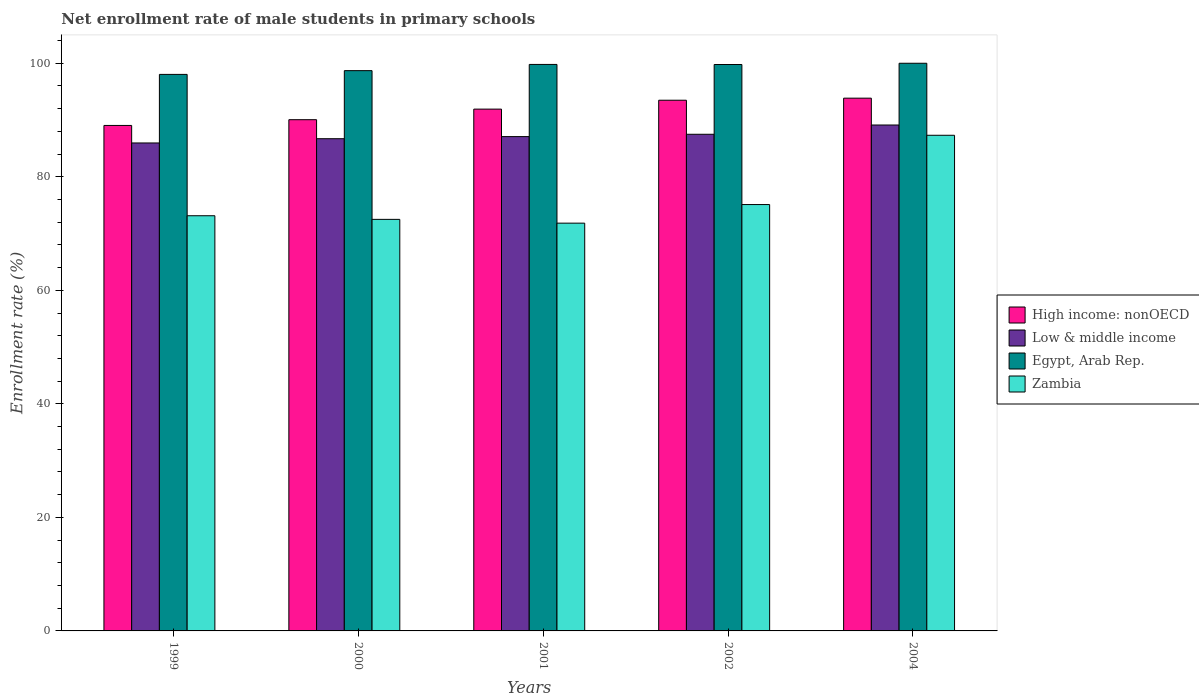Are the number of bars on each tick of the X-axis equal?
Offer a terse response. Yes. What is the net enrollment rate of male students in primary schools in Low & middle income in 2002?
Give a very brief answer. 87.49. Across all years, what is the maximum net enrollment rate of male students in primary schools in Egypt, Arab Rep.?
Offer a terse response. 100. Across all years, what is the minimum net enrollment rate of male students in primary schools in Zambia?
Offer a terse response. 71.83. In which year was the net enrollment rate of male students in primary schools in Egypt, Arab Rep. maximum?
Your answer should be compact. 2004. In which year was the net enrollment rate of male students in primary schools in High income: nonOECD minimum?
Provide a succinct answer. 1999. What is the total net enrollment rate of male students in primary schools in Egypt, Arab Rep. in the graph?
Make the answer very short. 496.3. What is the difference between the net enrollment rate of male students in primary schools in High income: nonOECD in 1999 and that in 2000?
Offer a very short reply. -1.01. What is the difference between the net enrollment rate of male students in primary schools in Low & middle income in 2000 and the net enrollment rate of male students in primary schools in Zambia in 2002?
Give a very brief answer. 11.6. What is the average net enrollment rate of male students in primary schools in Low & middle income per year?
Provide a succinct answer. 87.27. In the year 2001, what is the difference between the net enrollment rate of male students in primary schools in Zambia and net enrollment rate of male students in primary schools in Egypt, Arab Rep.?
Your answer should be very brief. -27.96. In how many years, is the net enrollment rate of male students in primary schools in High income: nonOECD greater than 44 %?
Offer a very short reply. 5. What is the ratio of the net enrollment rate of male students in primary schools in High income: nonOECD in 2002 to that in 2004?
Ensure brevity in your answer.  1. Is the difference between the net enrollment rate of male students in primary schools in Zambia in 1999 and 2001 greater than the difference between the net enrollment rate of male students in primary schools in Egypt, Arab Rep. in 1999 and 2001?
Keep it short and to the point. Yes. What is the difference between the highest and the second highest net enrollment rate of male students in primary schools in High income: nonOECD?
Keep it short and to the point. 0.36. What is the difference between the highest and the lowest net enrollment rate of male students in primary schools in Zambia?
Give a very brief answer. 15.48. Is the sum of the net enrollment rate of male students in primary schools in Low & middle income in 2000 and 2004 greater than the maximum net enrollment rate of male students in primary schools in Zambia across all years?
Your response must be concise. Yes. Is it the case that in every year, the sum of the net enrollment rate of male students in primary schools in Egypt, Arab Rep. and net enrollment rate of male students in primary schools in High income: nonOECD is greater than the sum of net enrollment rate of male students in primary schools in Low & middle income and net enrollment rate of male students in primary schools in Zambia?
Give a very brief answer. No. What does the 3rd bar from the left in 2002 represents?
Ensure brevity in your answer.  Egypt, Arab Rep. Is it the case that in every year, the sum of the net enrollment rate of male students in primary schools in High income: nonOECD and net enrollment rate of male students in primary schools in Zambia is greater than the net enrollment rate of male students in primary schools in Egypt, Arab Rep.?
Your answer should be compact. Yes. How many bars are there?
Ensure brevity in your answer.  20. Are all the bars in the graph horizontal?
Offer a terse response. No. How many years are there in the graph?
Offer a terse response. 5. What is the difference between two consecutive major ticks on the Y-axis?
Make the answer very short. 20. Are the values on the major ticks of Y-axis written in scientific E-notation?
Make the answer very short. No. Does the graph contain grids?
Make the answer very short. No. Where does the legend appear in the graph?
Offer a very short reply. Center right. How many legend labels are there?
Make the answer very short. 4. How are the legend labels stacked?
Provide a succinct answer. Vertical. What is the title of the graph?
Provide a succinct answer. Net enrollment rate of male students in primary schools. Does "Honduras" appear as one of the legend labels in the graph?
Make the answer very short. No. What is the label or title of the Y-axis?
Offer a terse response. Enrollment rate (%). What is the Enrollment rate (%) of High income: nonOECD in 1999?
Give a very brief answer. 89.04. What is the Enrollment rate (%) of Low & middle income in 1999?
Provide a succinct answer. 85.96. What is the Enrollment rate (%) in Egypt, Arab Rep. in 1999?
Provide a succinct answer. 98.04. What is the Enrollment rate (%) in Zambia in 1999?
Provide a short and direct response. 73.14. What is the Enrollment rate (%) of High income: nonOECD in 2000?
Ensure brevity in your answer.  90.06. What is the Enrollment rate (%) in Low & middle income in 2000?
Your answer should be very brief. 86.71. What is the Enrollment rate (%) of Egypt, Arab Rep. in 2000?
Your answer should be compact. 98.7. What is the Enrollment rate (%) in Zambia in 2000?
Provide a short and direct response. 72.5. What is the Enrollment rate (%) in High income: nonOECD in 2001?
Your answer should be very brief. 91.92. What is the Enrollment rate (%) of Low & middle income in 2001?
Make the answer very short. 87.08. What is the Enrollment rate (%) in Egypt, Arab Rep. in 2001?
Provide a short and direct response. 99.79. What is the Enrollment rate (%) of Zambia in 2001?
Your response must be concise. 71.83. What is the Enrollment rate (%) of High income: nonOECD in 2002?
Make the answer very short. 93.49. What is the Enrollment rate (%) in Low & middle income in 2002?
Your answer should be very brief. 87.49. What is the Enrollment rate (%) in Egypt, Arab Rep. in 2002?
Provide a short and direct response. 99.78. What is the Enrollment rate (%) of Zambia in 2002?
Provide a short and direct response. 75.11. What is the Enrollment rate (%) in High income: nonOECD in 2004?
Ensure brevity in your answer.  93.85. What is the Enrollment rate (%) in Low & middle income in 2004?
Provide a short and direct response. 89.12. What is the Enrollment rate (%) of Egypt, Arab Rep. in 2004?
Ensure brevity in your answer.  100. What is the Enrollment rate (%) of Zambia in 2004?
Your response must be concise. 87.31. Across all years, what is the maximum Enrollment rate (%) in High income: nonOECD?
Your answer should be compact. 93.85. Across all years, what is the maximum Enrollment rate (%) of Low & middle income?
Offer a terse response. 89.12. Across all years, what is the maximum Enrollment rate (%) of Egypt, Arab Rep.?
Ensure brevity in your answer.  100. Across all years, what is the maximum Enrollment rate (%) in Zambia?
Offer a terse response. 87.31. Across all years, what is the minimum Enrollment rate (%) in High income: nonOECD?
Offer a very short reply. 89.04. Across all years, what is the minimum Enrollment rate (%) of Low & middle income?
Your response must be concise. 85.96. Across all years, what is the minimum Enrollment rate (%) of Egypt, Arab Rep.?
Ensure brevity in your answer.  98.04. Across all years, what is the minimum Enrollment rate (%) of Zambia?
Give a very brief answer. 71.83. What is the total Enrollment rate (%) in High income: nonOECD in the graph?
Provide a short and direct response. 458.36. What is the total Enrollment rate (%) of Low & middle income in the graph?
Your answer should be very brief. 436.35. What is the total Enrollment rate (%) in Egypt, Arab Rep. in the graph?
Your answer should be very brief. 496.3. What is the total Enrollment rate (%) in Zambia in the graph?
Ensure brevity in your answer.  379.89. What is the difference between the Enrollment rate (%) in High income: nonOECD in 1999 and that in 2000?
Offer a very short reply. -1.01. What is the difference between the Enrollment rate (%) in Low & middle income in 1999 and that in 2000?
Ensure brevity in your answer.  -0.75. What is the difference between the Enrollment rate (%) of Egypt, Arab Rep. in 1999 and that in 2000?
Make the answer very short. -0.66. What is the difference between the Enrollment rate (%) of Zambia in 1999 and that in 2000?
Keep it short and to the point. 0.64. What is the difference between the Enrollment rate (%) of High income: nonOECD in 1999 and that in 2001?
Offer a very short reply. -2.88. What is the difference between the Enrollment rate (%) in Low & middle income in 1999 and that in 2001?
Provide a succinct answer. -1.12. What is the difference between the Enrollment rate (%) of Egypt, Arab Rep. in 1999 and that in 2001?
Offer a very short reply. -1.76. What is the difference between the Enrollment rate (%) in Zambia in 1999 and that in 2001?
Your answer should be very brief. 1.3. What is the difference between the Enrollment rate (%) of High income: nonOECD in 1999 and that in 2002?
Keep it short and to the point. -4.44. What is the difference between the Enrollment rate (%) of Low & middle income in 1999 and that in 2002?
Offer a terse response. -1.53. What is the difference between the Enrollment rate (%) of Egypt, Arab Rep. in 1999 and that in 2002?
Give a very brief answer. -1.74. What is the difference between the Enrollment rate (%) of Zambia in 1999 and that in 2002?
Your answer should be compact. -1.97. What is the difference between the Enrollment rate (%) of High income: nonOECD in 1999 and that in 2004?
Provide a short and direct response. -4.81. What is the difference between the Enrollment rate (%) of Low & middle income in 1999 and that in 2004?
Ensure brevity in your answer.  -3.16. What is the difference between the Enrollment rate (%) in Egypt, Arab Rep. in 1999 and that in 2004?
Your answer should be very brief. -1.96. What is the difference between the Enrollment rate (%) of Zambia in 1999 and that in 2004?
Give a very brief answer. -14.17. What is the difference between the Enrollment rate (%) of High income: nonOECD in 2000 and that in 2001?
Your response must be concise. -1.86. What is the difference between the Enrollment rate (%) of Low & middle income in 2000 and that in 2001?
Ensure brevity in your answer.  -0.37. What is the difference between the Enrollment rate (%) of Egypt, Arab Rep. in 2000 and that in 2001?
Keep it short and to the point. -1.1. What is the difference between the Enrollment rate (%) in Zambia in 2000 and that in 2001?
Ensure brevity in your answer.  0.67. What is the difference between the Enrollment rate (%) in High income: nonOECD in 2000 and that in 2002?
Keep it short and to the point. -3.43. What is the difference between the Enrollment rate (%) in Low & middle income in 2000 and that in 2002?
Make the answer very short. -0.78. What is the difference between the Enrollment rate (%) in Egypt, Arab Rep. in 2000 and that in 2002?
Ensure brevity in your answer.  -1.08. What is the difference between the Enrollment rate (%) in Zambia in 2000 and that in 2002?
Give a very brief answer. -2.61. What is the difference between the Enrollment rate (%) of High income: nonOECD in 2000 and that in 2004?
Provide a short and direct response. -3.79. What is the difference between the Enrollment rate (%) of Low & middle income in 2000 and that in 2004?
Your answer should be very brief. -2.41. What is the difference between the Enrollment rate (%) in Egypt, Arab Rep. in 2000 and that in 2004?
Provide a succinct answer. -1.3. What is the difference between the Enrollment rate (%) of Zambia in 2000 and that in 2004?
Provide a short and direct response. -14.81. What is the difference between the Enrollment rate (%) in High income: nonOECD in 2001 and that in 2002?
Your answer should be very brief. -1.57. What is the difference between the Enrollment rate (%) in Low & middle income in 2001 and that in 2002?
Ensure brevity in your answer.  -0.41. What is the difference between the Enrollment rate (%) of Egypt, Arab Rep. in 2001 and that in 2002?
Your answer should be very brief. 0.01. What is the difference between the Enrollment rate (%) in Zambia in 2001 and that in 2002?
Offer a terse response. -3.28. What is the difference between the Enrollment rate (%) in High income: nonOECD in 2001 and that in 2004?
Ensure brevity in your answer.  -1.93. What is the difference between the Enrollment rate (%) of Low & middle income in 2001 and that in 2004?
Make the answer very short. -2.04. What is the difference between the Enrollment rate (%) in Egypt, Arab Rep. in 2001 and that in 2004?
Give a very brief answer. -0.21. What is the difference between the Enrollment rate (%) in Zambia in 2001 and that in 2004?
Offer a very short reply. -15.48. What is the difference between the Enrollment rate (%) in High income: nonOECD in 2002 and that in 2004?
Make the answer very short. -0.36. What is the difference between the Enrollment rate (%) in Low & middle income in 2002 and that in 2004?
Keep it short and to the point. -1.63. What is the difference between the Enrollment rate (%) in Egypt, Arab Rep. in 2002 and that in 2004?
Your answer should be very brief. -0.22. What is the difference between the Enrollment rate (%) in Zambia in 2002 and that in 2004?
Offer a terse response. -12.2. What is the difference between the Enrollment rate (%) in High income: nonOECD in 1999 and the Enrollment rate (%) in Low & middle income in 2000?
Ensure brevity in your answer.  2.34. What is the difference between the Enrollment rate (%) of High income: nonOECD in 1999 and the Enrollment rate (%) of Egypt, Arab Rep. in 2000?
Ensure brevity in your answer.  -9.65. What is the difference between the Enrollment rate (%) of High income: nonOECD in 1999 and the Enrollment rate (%) of Zambia in 2000?
Offer a terse response. 16.54. What is the difference between the Enrollment rate (%) of Low & middle income in 1999 and the Enrollment rate (%) of Egypt, Arab Rep. in 2000?
Provide a succinct answer. -12.74. What is the difference between the Enrollment rate (%) in Low & middle income in 1999 and the Enrollment rate (%) in Zambia in 2000?
Provide a succinct answer. 13.46. What is the difference between the Enrollment rate (%) in Egypt, Arab Rep. in 1999 and the Enrollment rate (%) in Zambia in 2000?
Your response must be concise. 25.54. What is the difference between the Enrollment rate (%) of High income: nonOECD in 1999 and the Enrollment rate (%) of Low & middle income in 2001?
Provide a succinct answer. 1.96. What is the difference between the Enrollment rate (%) of High income: nonOECD in 1999 and the Enrollment rate (%) of Egypt, Arab Rep. in 2001?
Give a very brief answer. -10.75. What is the difference between the Enrollment rate (%) in High income: nonOECD in 1999 and the Enrollment rate (%) in Zambia in 2001?
Provide a short and direct response. 17.21. What is the difference between the Enrollment rate (%) in Low & middle income in 1999 and the Enrollment rate (%) in Egypt, Arab Rep. in 2001?
Keep it short and to the point. -13.84. What is the difference between the Enrollment rate (%) in Low & middle income in 1999 and the Enrollment rate (%) in Zambia in 2001?
Provide a short and direct response. 14.12. What is the difference between the Enrollment rate (%) of Egypt, Arab Rep. in 1999 and the Enrollment rate (%) of Zambia in 2001?
Provide a short and direct response. 26.2. What is the difference between the Enrollment rate (%) in High income: nonOECD in 1999 and the Enrollment rate (%) in Low & middle income in 2002?
Give a very brief answer. 1.56. What is the difference between the Enrollment rate (%) in High income: nonOECD in 1999 and the Enrollment rate (%) in Egypt, Arab Rep. in 2002?
Your answer should be very brief. -10.73. What is the difference between the Enrollment rate (%) in High income: nonOECD in 1999 and the Enrollment rate (%) in Zambia in 2002?
Offer a very short reply. 13.93. What is the difference between the Enrollment rate (%) of Low & middle income in 1999 and the Enrollment rate (%) of Egypt, Arab Rep. in 2002?
Your answer should be compact. -13.82. What is the difference between the Enrollment rate (%) in Low & middle income in 1999 and the Enrollment rate (%) in Zambia in 2002?
Make the answer very short. 10.85. What is the difference between the Enrollment rate (%) in Egypt, Arab Rep. in 1999 and the Enrollment rate (%) in Zambia in 2002?
Provide a short and direct response. 22.93. What is the difference between the Enrollment rate (%) in High income: nonOECD in 1999 and the Enrollment rate (%) in Low & middle income in 2004?
Ensure brevity in your answer.  -0.08. What is the difference between the Enrollment rate (%) in High income: nonOECD in 1999 and the Enrollment rate (%) in Egypt, Arab Rep. in 2004?
Your response must be concise. -10.95. What is the difference between the Enrollment rate (%) in High income: nonOECD in 1999 and the Enrollment rate (%) in Zambia in 2004?
Your answer should be compact. 1.73. What is the difference between the Enrollment rate (%) of Low & middle income in 1999 and the Enrollment rate (%) of Egypt, Arab Rep. in 2004?
Provide a short and direct response. -14.04. What is the difference between the Enrollment rate (%) in Low & middle income in 1999 and the Enrollment rate (%) in Zambia in 2004?
Make the answer very short. -1.35. What is the difference between the Enrollment rate (%) of Egypt, Arab Rep. in 1999 and the Enrollment rate (%) of Zambia in 2004?
Your response must be concise. 10.73. What is the difference between the Enrollment rate (%) in High income: nonOECD in 2000 and the Enrollment rate (%) in Low & middle income in 2001?
Offer a very short reply. 2.98. What is the difference between the Enrollment rate (%) in High income: nonOECD in 2000 and the Enrollment rate (%) in Egypt, Arab Rep. in 2001?
Ensure brevity in your answer.  -9.74. What is the difference between the Enrollment rate (%) of High income: nonOECD in 2000 and the Enrollment rate (%) of Zambia in 2001?
Your response must be concise. 18.22. What is the difference between the Enrollment rate (%) of Low & middle income in 2000 and the Enrollment rate (%) of Egypt, Arab Rep. in 2001?
Your answer should be very brief. -13.09. What is the difference between the Enrollment rate (%) in Low & middle income in 2000 and the Enrollment rate (%) in Zambia in 2001?
Provide a succinct answer. 14.87. What is the difference between the Enrollment rate (%) in Egypt, Arab Rep. in 2000 and the Enrollment rate (%) in Zambia in 2001?
Provide a succinct answer. 26.86. What is the difference between the Enrollment rate (%) of High income: nonOECD in 2000 and the Enrollment rate (%) of Low & middle income in 2002?
Keep it short and to the point. 2.57. What is the difference between the Enrollment rate (%) of High income: nonOECD in 2000 and the Enrollment rate (%) of Egypt, Arab Rep. in 2002?
Offer a terse response. -9.72. What is the difference between the Enrollment rate (%) in High income: nonOECD in 2000 and the Enrollment rate (%) in Zambia in 2002?
Your answer should be compact. 14.95. What is the difference between the Enrollment rate (%) of Low & middle income in 2000 and the Enrollment rate (%) of Egypt, Arab Rep. in 2002?
Ensure brevity in your answer.  -13.07. What is the difference between the Enrollment rate (%) of Low & middle income in 2000 and the Enrollment rate (%) of Zambia in 2002?
Make the answer very short. 11.6. What is the difference between the Enrollment rate (%) in Egypt, Arab Rep. in 2000 and the Enrollment rate (%) in Zambia in 2002?
Provide a succinct answer. 23.59. What is the difference between the Enrollment rate (%) in High income: nonOECD in 2000 and the Enrollment rate (%) in Low & middle income in 2004?
Provide a succinct answer. 0.94. What is the difference between the Enrollment rate (%) of High income: nonOECD in 2000 and the Enrollment rate (%) of Egypt, Arab Rep. in 2004?
Offer a very short reply. -9.94. What is the difference between the Enrollment rate (%) of High income: nonOECD in 2000 and the Enrollment rate (%) of Zambia in 2004?
Ensure brevity in your answer.  2.74. What is the difference between the Enrollment rate (%) in Low & middle income in 2000 and the Enrollment rate (%) in Egypt, Arab Rep. in 2004?
Offer a very short reply. -13.29. What is the difference between the Enrollment rate (%) in Low & middle income in 2000 and the Enrollment rate (%) in Zambia in 2004?
Your answer should be compact. -0.6. What is the difference between the Enrollment rate (%) in Egypt, Arab Rep. in 2000 and the Enrollment rate (%) in Zambia in 2004?
Give a very brief answer. 11.38. What is the difference between the Enrollment rate (%) of High income: nonOECD in 2001 and the Enrollment rate (%) of Low & middle income in 2002?
Offer a terse response. 4.43. What is the difference between the Enrollment rate (%) of High income: nonOECD in 2001 and the Enrollment rate (%) of Egypt, Arab Rep. in 2002?
Make the answer very short. -7.86. What is the difference between the Enrollment rate (%) in High income: nonOECD in 2001 and the Enrollment rate (%) in Zambia in 2002?
Ensure brevity in your answer.  16.81. What is the difference between the Enrollment rate (%) in Low & middle income in 2001 and the Enrollment rate (%) in Egypt, Arab Rep. in 2002?
Your answer should be compact. -12.7. What is the difference between the Enrollment rate (%) of Low & middle income in 2001 and the Enrollment rate (%) of Zambia in 2002?
Keep it short and to the point. 11.97. What is the difference between the Enrollment rate (%) of Egypt, Arab Rep. in 2001 and the Enrollment rate (%) of Zambia in 2002?
Give a very brief answer. 24.68. What is the difference between the Enrollment rate (%) of High income: nonOECD in 2001 and the Enrollment rate (%) of Low & middle income in 2004?
Make the answer very short. 2.8. What is the difference between the Enrollment rate (%) of High income: nonOECD in 2001 and the Enrollment rate (%) of Egypt, Arab Rep. in 2004?
Your answer should be compact. -8.08. What is the difference between the Enrollment rate (%) of High income: nonOECD in 2001 and the Enrollment rate (%) of Zambia in 2004?
Offer a very short reply. 4.61. What is the difference between the Enrollment rate (%) in Low & middle income in 2001 and the Enrollment rate (%) in Egypt, Arab Rep. in 2004?
Provide a succinct answer. -12.92. What is the difference between the Enrollment rate (%) of Low & middle income in 2001 and the Enrollment rate (%) of Zambia in 2004?
Your answer should be very brief. -0.23. What is the difference between the Enrollment rate (%) of Egypt, Arab Rep. in 2001 and the Enrollment rate (%) of Zambia in 2004?
Keep it short and to the point. 12.48. What is the difference between the Enrollment rate (%) in High income: nonOECD in 2002 and the Enrollment rate (%) in Low & middle income in 2004?
Your answer should be compact. 4.37. What is the difference between the Enrollment rate (%) of High income: nonOECD in 2002 and the Enrollment rate (%) of Egypt, Arab Rep. in 2004?
Your answer should be very brief. -6.51. What is the difference between the Enrollment rate (%) of High income: nonOECD in 2002 and the Enrollment rate (%) of Zambia in 2004?
Keep it short and to the point. 6.18. What is the difference between the Enrollment rate (%) of Low & middle income in 2002 and the Enrollment rate (%) of Egypt, Arab Rep. in 2004?
Keep it short and to the point. -12.51. What is the difference between the Enrollment rate (%) of Low & middle income in 2002 and the Enrollment rate (%) of Zambia in 2004?
Your response must be concise. 0.18. What is the difference between the Enrollment rate (%) of Egypt, Arab Rep. in 2002 and the Enrollment rate (%) of Zambia in 2004?
Provide a short and direct response. 12.47. What is the average Enrollment rate (%) in High income: nonOECD per year?
Offer a terse response. 91.67. What is the average Enrollment rate (%) in Low & middle income per year?
Give a very brief answer. 87.27. What is the average Enrollment rate (%) of Egypt, Arab Rep. per year?
Keep it short and to the point. 99.26. What is the average Enrollment rate (%) in Zambia per year?
Keep it short and to the point. 75.98. In the year 1999, what is the difference between the Enrollment rate (%) in High income: nonOECD and Enrollment rate (%) in Low & middle income?
Make the answer very short. 3.09. In the year 1999, what is the difference between the Enrollment rate (%) of High income: nonOECD and Enrollment rate (%) of Egypt, Arab Rep.?
Provide a succinct answer. -8.99. In the year 1999, what is the difference between the Enrollment rate (%) of High income: nonOECD and Enrollment rate (%) of Zambia?
Give a very brief answer. 15.91. In the year 1999, what is the difference between the Enrollment rate (%) in Low & middle income and Enrollment rate (%) in Egypt, Arab Rep.?
Provide a succinct answer. -12.08. In the year 1999, what is the difference between the Enrollment rate (%) in Low & middle income and Enrollment rate (%) in Zambia?
Give a very brief answer. 12.82. In the year 1999, what is the difference between the Enrollment rate (%) of Egypt, Arab Rep. and Enrollment rate (%) of Zambia?
Provide a short and direct response. 24.9. In the year 2000, what is the difference between the Enrollment rate (%) in High income: nonOECD and Enrollment rate (%) in Low & middle income?
Offer a terse response. 3.35. In the year 2000, what is the difference between the Enrollment rate (%) of High income: nonOECD and Enrollment rate (%) of Egypt, Arab Rep.?
Make the answer very short. -8.64. In the year 2000, what is the difference between the Enrollment rate (%) of High income: nonOECD and Enrollment rate (%) of Zambia?
Your answer should be very brief. 17.56. In the year 2000, what is the difference between the Enrollment rate (%) in Low & middle income and Enrollment rate (%) in Egypt, Arab Rep.?
Ensure brevity in your answer.  -11.99. In the year 2000, what is the difference between the Enrollment rate (%) of Low & middle income and Enrollment rate (%) of Zambia?
Provide a succinct answer. 14.21. In the year 2000, what is the difference between the Enrollment rate (%) in Egypt, Arab Rep. and Enrollment rate (%) in Zambia?
Your response must be concise. 26.2. In the year 2001, what is the difference between the Enrollment rate (%) in High income: nonOECD and Enrollment rate (%) in Low & middle income?
Your answer should be compact. 4.84. In the year 2001, what is the difference between the Enrollment rate (%) of High income: nonOECD and Enrollment rate (%) of Egypt, Arab Rep.?
Provide a succinct answer. -7.87. In the year 2001, what is the difference between the Enrollment rate (%) in High income: nonOECD and Enrollment rate (%) in Zambia?
Offer a terse response. 20.09. In the year 2001, what is the difference between the Enrollment rate (%) of Low & middle income and Enrollment rate (%) of Egypt, Arab Rep.?
Offer a terse response. -12.71. In the year 2001, what is the difference between the Enrollment rate (%) in Low & middle income and Enrollment rate (%) in Zambia?
Provide a succinct answer. 15.25. In the year 2001, what is the difference between the Enrollment rate (%) in Egypt, Arab Rep. and Enrollment rate (%) in Zambia?
Provide a succinct answer. 27.96. In the year 2002, what is the difference between the Enrollment rate (%) of High income: nonOECD and Enrollment rate (%) of Low & middle income?
Make the answer very short. 6. In the year 2002, what is the difference between the Enrollment rate (%) in High income: nonOECD and Enrollment rate (%) in Egypt, Arab Rep.?
Offer a very short reply. -6.29. In the year 2002, what is the difference between the Enrollment rate (%) of High income: nonOECD and Enrollment rate (%) of Zambia?
Offer a terse response. 18.38. In the year 2002, what is the difference between the Enrollment rate (%) of Low & middle income and Enrollment rate (%) of Egypt, Arab Rep.?
Your response must be concise. -12.29. In the year 2002, what is the difference between the Enrollment rate (%) of Low & middle income and Enrollment rate (%) of Zambia?
Your answer should be compact. 12.38. In the year 2002, what is the difference between the Enrollment rate (%) in Egypt, Arab Rep. and Enrollment rate (%) in Zambia?
Your answer should be very brief. 24.67. In the year 2004, what is the difference between the Enrollment rate (%) of High income: nonOECD and Enrollment rate (%) of Low & middle income?
Provide a short and direct response. 4.73. In the year 2004, what is the difference between the Enrollment rate (%) in High income: nonOECD and Enrollment rate (%) in Egypt, Arab Rep.?
Your answer should be compact. -6.15. In the year 2004, what is the difference between the Enrollment rate (%) of High income: nonOECD and Enrollment rate (%) of Zambia?
Your answer should be very brief. 6.54. In the year 2004, what is the difference between the Enrollment rate (%) of Low & middle income and Enrollment rate (%) of Egypt, Arab Rep.?
Keep it short and to the point. -10.88. In the year 2004, what is the difference between the Enrollment rate (%) of Low & middle income and Enrollment rate (%) of Zambia?
Offer a very short reply. 1.81. In the year 2004, what is the difference between the Enrollment rate (%) of Egypt, Arab Rep. and Enrollment rate (%) of Zambia?
Make the answer very short. 12.69. What is the ratio of the Enrollment rate (%) of High income: nonOECD in 1999 to that in 2000?
Your answer should be very brief. 0.99. What is the ratio of the Enrollment rate (%) of Zambia in 1999 to that in 2000?
Provide a succinct answer. 1.01. What is the ratio of the Enrollment rate (%) in High income: nonOECD in 1999 to that in 2001?
Provide a succinct answer. 0.97. What is the ratio of the Enrollment rate (%) in Low & middle income in 1999 to that in 2001?
Offer a very short reply. 0.99. What is the ratio of the Enrollment rate (%) of Egypt, Arab Rep. in 1999 to that in 2001?
Your response must be concise. 0.98. What is the ratio of the Enrollment rate (%) in Zambia in 1999 to that in 2001?
Provide a short and direct response. 1.02. What is the ratio of the Enrollment rate (%) in High income: nonOECD in 1999 to that in 2002?
Your answer should be compact. 0.95. What is the ratio of the Enrollment rate (%) in Low & middle income in 1999 to that in 2002?
Ensure brevity in your answer.  0.98. What is the ratio of the Enrollment rate (%) of Egypt, Arab Rep. in 1999 to that in 2002?
Offer a very short reply. 0.98. What is the ratio of the Enrollment rate (%) of Zambia in 1999 to that in 2002?
Your answer should be very brief. 0.97. What is the ratio of the Enrollment rate (%) of High income: nonOECD in 1999 to that in 2004?
Your answer should be compact. 0.95. What is the ratio of the Enrollment rate (%) in Low & middle income in 1999 to that in 2004?
Your answer should be compact. 0.96. What is the ratio of the Enrollment rate (%) of Egypt, Arab Rep. in 1999 to that in 2004?
Your answer should be compact. 0.98. What is the ratio of the Enrollment rate (%) in Zambia in 1999 to that in 2004?
Keep it short and to the point. 0.84. What is the ratio of the Enrollment rate (%) in High income: nonOECD in 2000 to that in 2001?
Give a very brief answer. 0.98. What is the ratio of the Enrollment rate (%) of Zambia in 2000 to that in 2001?
Provide a succinct answer. 1.01. What is the ratio of the Enrollment rate (%) in High income: nonOECD in 2000 to that in 2002?
Keep it short and to the point. 0.96. What is the ratio of the Enrollment rate (%) in Zambia in 2000 to that in 2002?
Keep it short and to the point. 0.97. What is the ratio of the Enrollment rate (%) in High income: nonOECD in 2000 to that in 2004?
Provide a short and direct response. 0.96. What is the ratio of the Enrollment rate (%) in Low & middle income in 2000 to that in 2004?
Ensure brevity in your answer.  0.97. What is the ratio of the Enrollment rate (%) in Zambia in 2000 to that in 2004?
Provide a short and direct response. 0.83. What is the ratio of the Enrollment rate (%) in High income: nonOECD in 2001 to that in 2002?
Your answer should be compact. 0.98. What is the ratio of the Enrollment rate (%) in Egypt, Arab Rep. in 2001 to that in 2002?
Provide a short and direct response. 1. What is the ratio of the Enrollment rate (%) of Zambia in 2001 to that in 2002?
Offer a very short reply. 0.96. What is the ratio of the Enrollment rate (%) of High income: nonOECD in 2001 to that in 2004?
Ensure brevity in your answer.  0.98. What is the ratio of the Enrollment rate (%) of Low & middle income in 2001 to that in 2004?
Your response must be concise. 0.98. What is the ratio of the Enrollment rate (%) of Zambia in 2001 to that in 2004?
Your answer should be very brief. 0.82. What is the ratio of the Enrollment rate (%) of Low & middle income in 2002 to that in 2004?
Provide a succinct answer. 0.98. What is the ratio of the Enrollment rate (%) of Egypt, Arab Rep. in 2002 to that in 2004?
Offer a very short reply. 1. What is the ratio of the Enrollment rate (%) in Zambia in 2002 to that in 2004?
Ensure brevity in your answer.  0.86. What is the difference between the highest and the second highest Enrollment rate (%) of High income: nonOECD?
Your answer should be very brief. 0.36. What is the difference between the highest and the second highest Enrollment rate (%) in Low & middle income?
Ensure brevity in your answer.  1.63. What is the difference between the highest and the second highest Enrollment rate (%) of Egypt, Arab Rep.?
Your answer should be compact. 0.21. What is the difference between the highest and the second highest Enrollment rate (%) of Zambia?
Your response must be concise. 12.2. What is the difference between the highest and the lowest Enrollment rate (%) of High income: nonOECD?
Offer a very short reply. 4.81. What is the difference between the highest and the lowest Enrollment rate (%) of Low & middle income?
Your answer should be compact. 3.16. What is the difference between the highest and the lowest Enrollment rate (%) in Egypt, Arab Rep.?
Your answer should be compact. 1.96. What is the difference between the highest and the lowest Enrollment rate (%) of Zambia?
Keep it short and to the point. 15.48. 